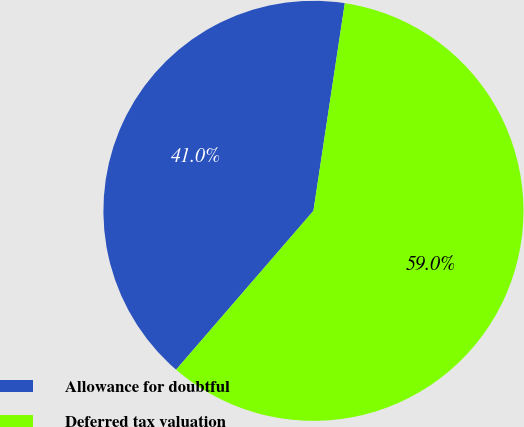<chart> <loc_0><loc_0><loc_500><loc_500><pie_chart><fcel>Allowance for doubtful<fcel>Deferred tax valuation<nl><fcel>41.04%<fcel>58.96%<nl></chart> 